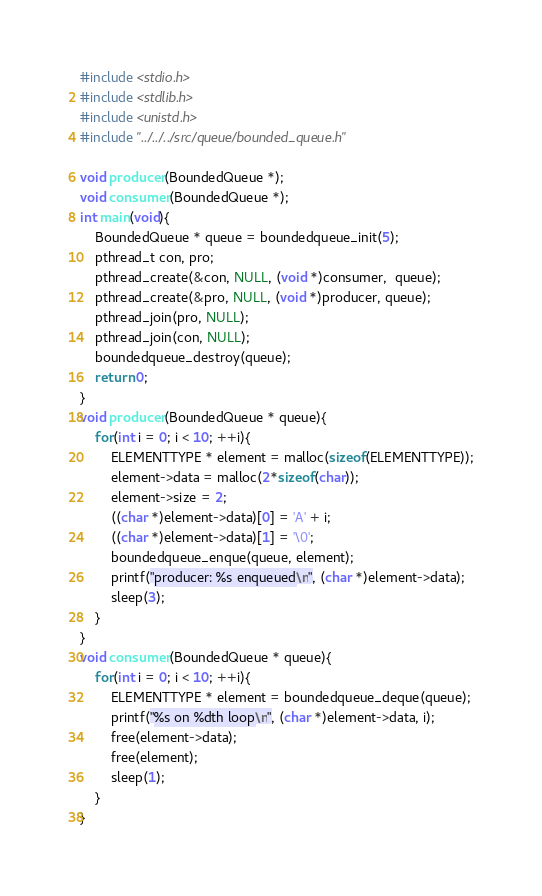Convert code to text. <code><loc_0><loc_0><loc_500><loc_500><_C_>#include <stdio.h>
#include <stdlib.h>
#include <unistd.h>
#include "../../../src/queue/bounded_queue.h"

void producer(BoundedQueue *);
void consumer(BoundedQueue *);
int main(void){
	BoundedQueue * queue = boundedqueue_init(5);
	pthread_t con, pro;
	pthread_create(&con, NULL, (void *)consumer,  queue);
	pthread_create(&pro, NULL, (void *)producer, queue);
	pthread_join(pro, NULL);
	pthread_join(con, NULL);
	boundedqueue_destroy(queue);
	return 0;
}
void producer(BoundedQueue * queue){
	for(int i = 0; i < 10; ++i){
		ELEMENTTYPE * element = malloc(sizeof(ELEMENTTYPE));
		element->data = malloc(2*sizeof(char));
		element->size = 2;
		((char *)element->data)[0] = 'A' + i;
		((char *)element->data)[1] = '\0';
		boundedqueue_enque(queue, element);
		printf("producer: %s enqueued\n", (char *)element->data);
		sleep(3);
	}
}
void consumer(BoundedQueue * queue){
	for(int i = 0; i < 10; ++i){
		ELEMENTTYPE * element = boundedqueue_deque(queue);
		printf("%s on %dth loop\n", (char *)element->data, i);
		free(element->data);
		free(element);
		sleep(1);
	}
}
</code> 